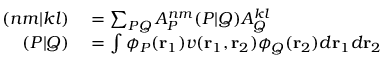<formula> <loc_0><loc_0><loc_500><loc_500>\begin{array} { r l } { ( n m | k l ) } & = \sum _ { P Q } A _ { P } ^ { n m } ( P | Q ) A _ { Q } ^ { k l } } \\ { ( P | Q ) } & = \int \phi _ { P } ( r _ { 1 } ) v ( r _ { 1 } , r _ { 2 } ) \phi _ { Q } ( r _ { 2 } ) d r _ { 1 } d r _ { 2 } } \end{array}</formula> 